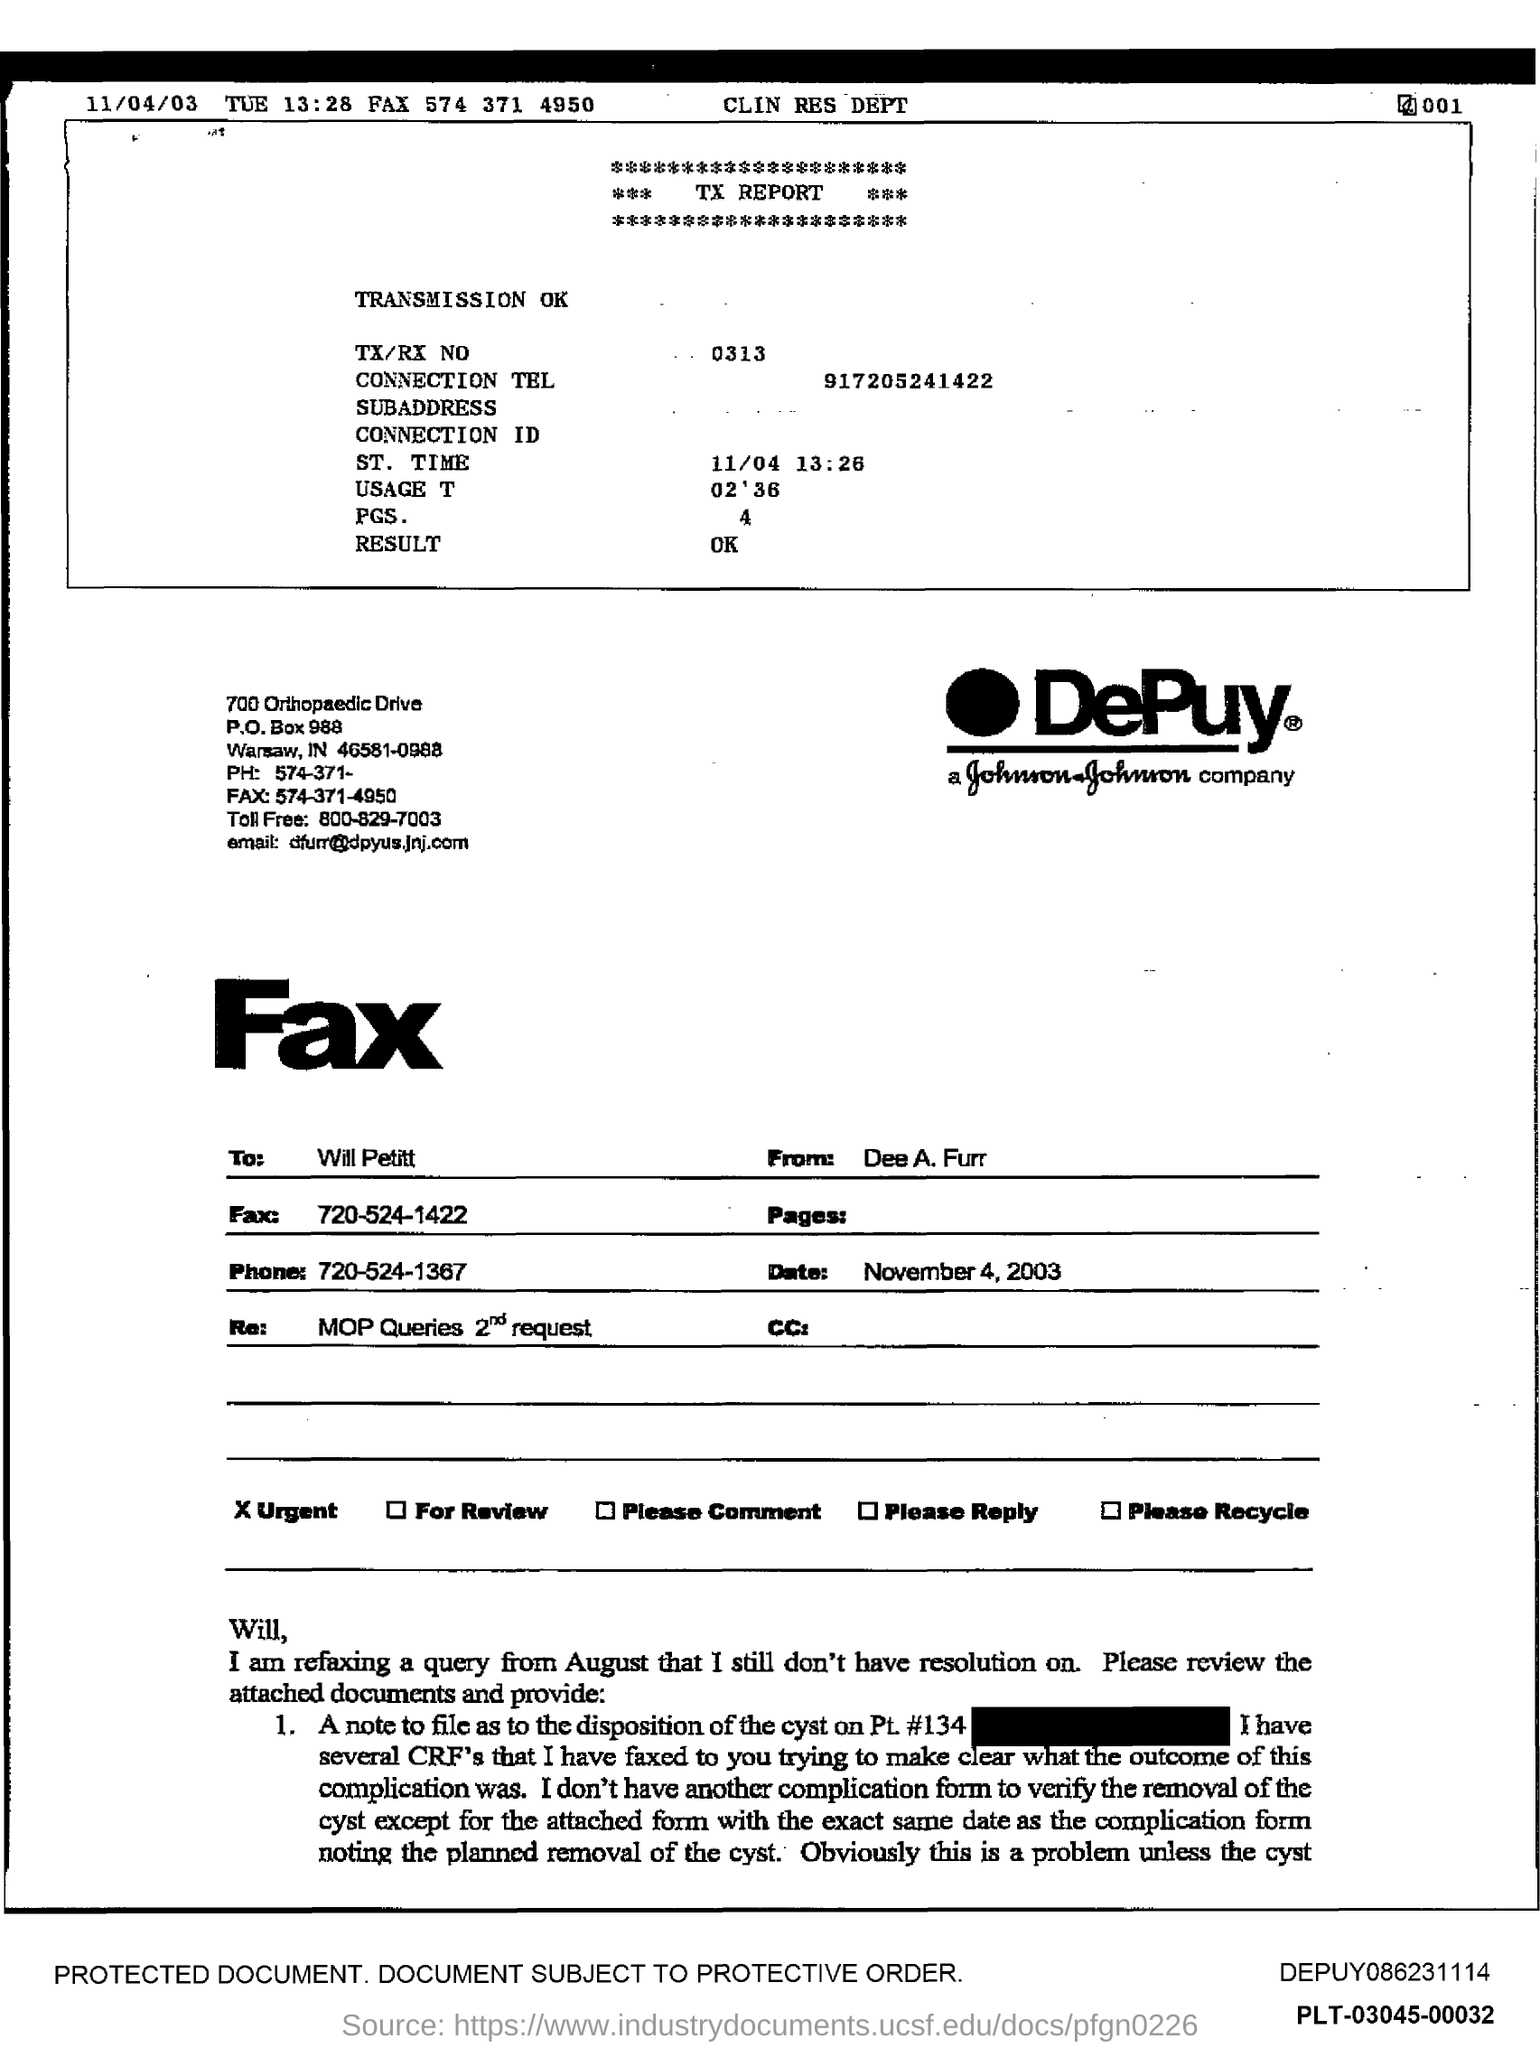What is the date given on the left?
Give a very brief answer. 11/04/03. What is the Fax number given?
Provide a short and direct response. 574 371 4950. What is the connection tel?
Make the answer very short. 917205241422. What is the TX/RX NO?
Make the answer very short. 0313. Which company's name is mentioned?
Make the answer very short. DePuy. What is the Toll free number given?
Provide a short and direct response. 800-829-7003. To whom is the fax addressed?
Your response must be concise. Will Petitt. Who is the sender?
Provide a short and direct response. Dee A. Furr. What is the date given on the form?
Ensure brevity in your answer.  November 4, 2003. 